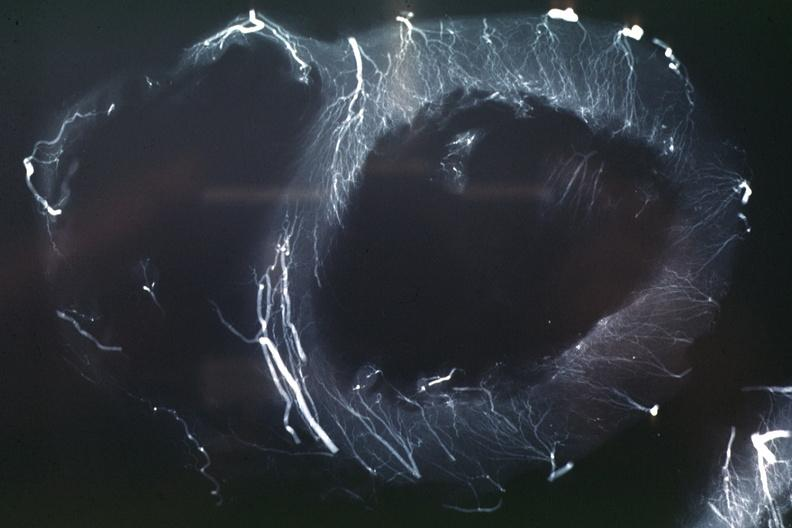does nipple duplication show x-ray postmortinjection horizontal slice of left ventricle showing very well penetrating arteries?
Answer the question using a single word or phrase. No 